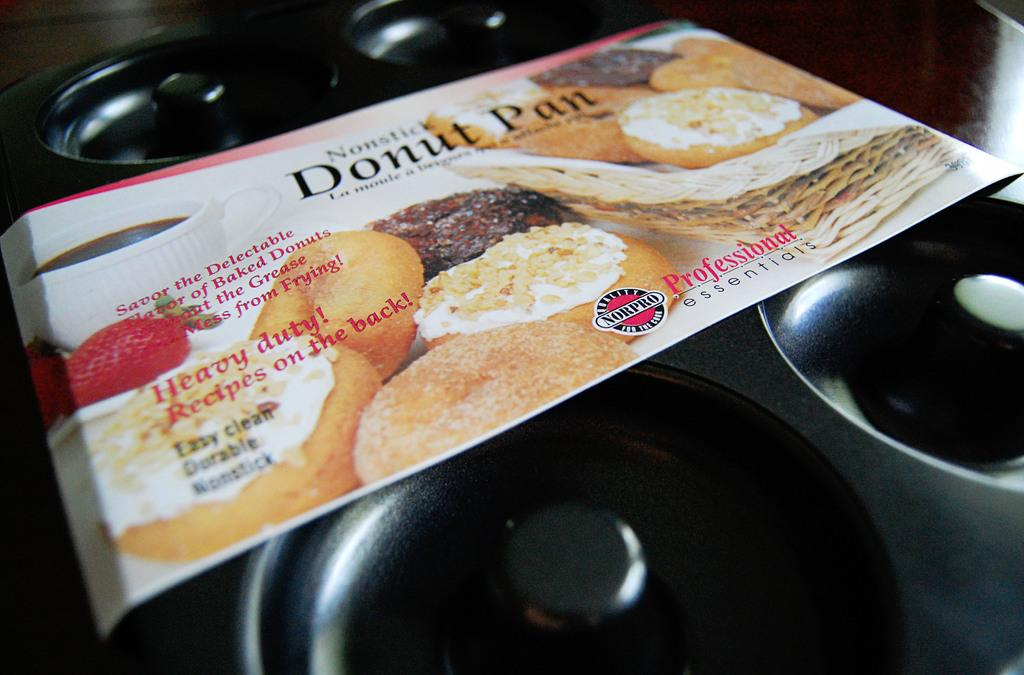What is on the table in the image? There is a pan on the table in the image. What additional detail can be observed about the pan? There is a label with text attached to the pan. How many cabbages are visible on top of the pan in the image? There are no cabbages visible in the image, and the pan is on the table, not on top of anything. 